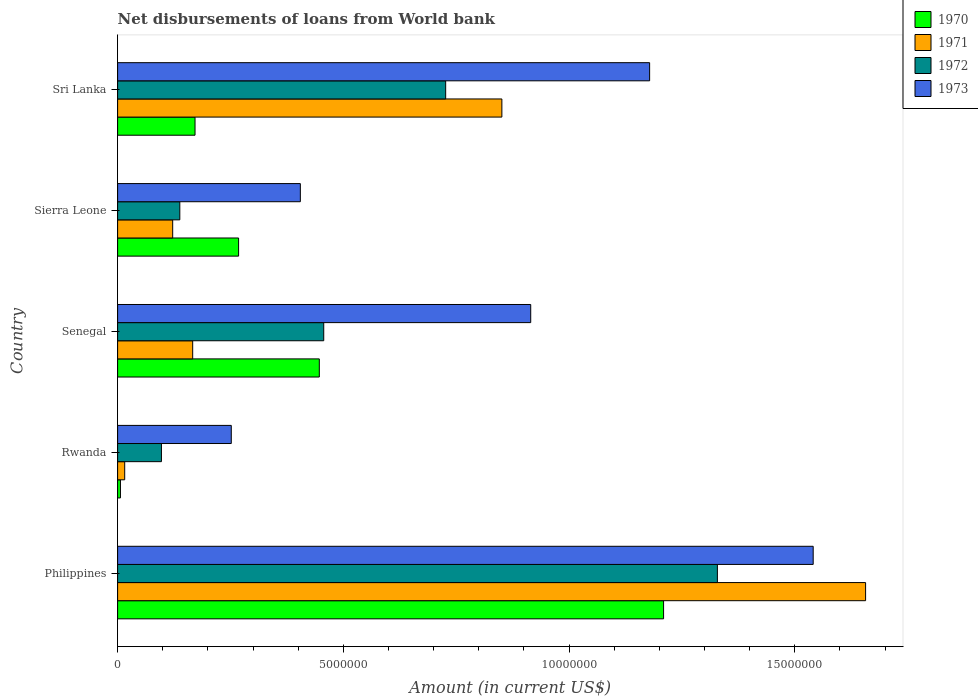Are the number of bars on each tick of the Y-axis equal?
Offer a terse response. Yes. How many bars are there on the 1st tick from the top?
Provide a short and direct response. 4. How many bars are there on the 1st tick from the bottom?
Give a very brief answer. 4. What is the label of the 1st group of bars from the top?
Your response must be concise. Sri Lanka. What is the amount of loan disbursed from World Bank in 1971 in Rwanda?
Your response must be concise. 1.57e+05. Across all countries, what is the maximum amount of loan disbursed from World Bank in 1970?
Provide a short and direct response. 1.21e+07. Across all countries, what is the minimum amount of loan disbursed from World Bank in 1970?
Give a very brief answer. 6.30e+04. In which country was the amount of loan disbursed from World Bank in 1973 maximum?
Your response must be concise. Philippines. In which country was the amount of loan disbursed from World Bank in 1973 minimum?
Ensure brevity in your answer.  Rwanda. What is the total amount of loan disbursed from World Bank in 1971 in the graph?
Provide a short and direct response. 2.81e+07. What is the difference between the amount of loan disbursed from World Bank in 1973 in Philippines and that in Sierra Leone?
Your response must be concise. 1.14e+07. What is the difference between the amount of loan disbursed from World Bank in 1971 in Rwanda and the amount of loan disbursed from World Bank in 1970 in Philippines?
Make the answer very short. -1.19e+07. What is the average amount of loan disbursed from World Bank in 1971 per country?
Make the answer very short. 5.62e+06. What is the difference between the amount of loan disbursed from World Bank in 1972 and amount of loan disbursed from World Bank in 1970 in Rwanda?
Provide a short and direct response. 9.08e+05. In how many countries, is the amount of loan disbursed from World Bank in 1970 greater than 1000000 US$?
Give a very brief answer. 4. What is the ratio of the amount of loan disbursed from World Bank in 1971 in Rwanda to that in Senegal?
Your response must be concise. 0.09. What is the difference between the highest and the second highest amount of loan disbursed from World Bank in 1973?
Give a very brief answer. 3.62e+06. What is the difference between the highest and the lowest amount of loan disbursed from World Bank in 1970?
Your response must be concise. 1.20e+07. In how many countries, is the amount of loan disbursed from World Bank in 1971 greater than the average amount of loan disbursed from World Bank in 1971 taken over all countries?
Offer a very short reply. 2. Is the sum of the amount of loan disbursed from World Bank in 1971 in Sierra Leone and Sri Lanka greater than the maximum amount of loan disbursed from World Bank in 1970 across all countries?
Give a very brief answer. No. What does the 3rd bar from the top in Senegal represents?
Make the answer very short. 1971. How many bars are there?
Offer a very short reply. 20. Are all the bars in the graph horizontal?
Offer a very short reply. Yes. What is the difference between two consecutive major ticks on the X-axis?
Provide a short and direct response. 5.00e+06. Does the graph contain any zero values?
Your response must be concise. No. Does the graph contain grids?
Make the answer very short. No. What is the title of the graph?
Your response must be concise. Net disbursements of loans from World bank. Does "2005" appear as one of the legend labels in the graph?
Offer a very short reply. No. What is the label or title of the X-axis?
Your answer should be very brief. Amount (in current US$). What is the Amount (in current US$) of 1970 in Philippines?
Your answer should be compact. 1.21e+07. What is the Amount (in current US$) of 1971 in Philippines?
Your answer should be compact. 1.66e+07. What is the Amount (in current US$) of 1972 in Philippines?
Ensure brevity in your answer.  1.33e+07. What is the Amount (in current US$) in 1973 in Philippines?
Provide a short and direct response. 1.54e+07. What is the Amount (in current US$) of 1970 in Rwanda?
Your answer should be compact. 6.30e+04. What is the Amount (in current US$) in 1971 in Rwanda?
Make the answer very short. 1.57e+05. What is the Amount (in current US$) of 1972 in Rwanda?
Your response must be concise. 9.71e+05. What is the Amount (in current US$) in 1973 in Rwanda?
Provide a succinct answer. 2.52e+06. What is the Amount (in current US$) in 1970 in Senegal?
Your answer should be very brief. 4.47e+06. What is the Amount (in current US$) in 1971 in Senegal?
Provide a succinct answer. 1.66e+06. What is the Amount (in current US$) of 1972 in Senegal?
Offer a very short reply. 4.57e+06. What is the Amount (in current US$) of 1973 in Senegal?
Keep it short and to the point. 9.15e+06. What is the Amount (in current US$) in 1970 in Sierra Leone?
Offer a very short reply. 2.68e+06. What is the Amount (in current US$) of 1971 in Sierra Leone?
Offer a terse response. 1.22e+06. What is the Amount (in current US$) of 1972 in Sierra Leone?
Keep it short and to the point. 1.38e+06. What is the Amount (in current US$) in 1973 in Sierra Leone?
Offer a very short reply. 4.05e+06. What is the Amount (in current US$) in 1970 in Sri Lanka?
Keep it short and to the point. 1.72e+06. What is the Amount (in current US$) of 1971 in Sri Lanka?
Your response must be concise. 8.51e+06. What is the Amount (in current US$) in 1972 in Sri Lanka?
Your response must be concise. 7.27e+06. What is the Amount (in current US$) in 1973 in Sri Lanka?
Provide a succinct answer. 1.18e+07. Across all countries, what is the maximum Amount (in current US$) of 1970?
Keep it short and to the point. 1.21e+07. Across all countries, what is the maximum Amount (in current US$) of 1971?
Keep it short and to the point. 1.66e+07. Across all countries, what is the maximum Amount (in current US$) of 1972?
Your answer should be compact. 1.33e+07. Across all countries, what is the maximum Amount (in current US$) of 1973?
Your answer should be very brief. 1.54e+07. Across all countries, what is the minimum Amount (in current US$) in 1970?
Provide a succinct answer. 6.30e+04. Across all countries, what is the minimum Amount (in current US$) in 1971?
Your answer should be compact. 1.57e+05. Across all countries, what is the minimum Amount (in current US$) of 1972?
Your response must be concise. 9.71e+05. Across all countries, what is the minimum Amount (in current US$) in 1973?
Provide a succinct answer. 2.52e+06. What is the total Amount (in current US$) in 1970 in the graph?
Your response must be concise. 2.10e+07. What is the total Amount (in current US$) of 1971 in the graph?
Your answer should be very brief. 2.81e+07. What is the total Amount (in current US$) in 1972 in the graph?
Make the answer very short. 2.75e+07. What is the total Amount (in current US$) of 1973 in the graph?
Keep it short and to the point. 4.29e+07. What is the difference between the Amount (in current US$) in 1970 in Philippines and that in Rwanda?
Ensure brevity in your answer.  1.20e+07. What is the difference between the Amount (in current US$) of 1971 in Philippines and that in Rwanda?
Give a very brief answer. 1.64e+07. What is the difference between the Amount (in current US$) in 1972 in Philippines and that in Rwanda?
Provide a short and direct response. 1.23e+07. What is the difference between the Amount (in current US$) in 1973 in Philippines and that in Rwanda?
Offer a terse response. 1.29e+07. What is the difference between the Amount (in current US$) in 1970 in Philippines and that in Senegal?
Your answer should be compact. 7.63e+06. What is the difference between the Amount (in current US$) in 1971 in Philippines and that in Senegal?
Your response must be concise. 1.49e+07. What is the difference between the Amount (in current US$) of 1972 in Philippines and that in Senegal?
Keep it short and to the point. 8.72e+06. What is the difference between the Amount (in current US$) of 1973 in Philippines and that in Senegal?
Give a very brief answer. 6.26e+06. What is the difference between the Amount (in current US$) in 1970 in Philippines and that in Sierra Leone?
Make the answer very short. 9.41e+06. What is the difference between the Amount (in current US$) of 1971 in Philippines and that in Sierra Leone?
Make the answer very short. 1.53e+07. What is the difference between the Amount (in current US$) in 1972 in Philippines and that in Sierra Leone?
Provide a short and direct response. 1.19e+07. What is the difference between the Amount (in current US$) of 1973 in Philippines and that in Sierra Leone?
Your answer should be compact. 1.14e+07. What is the difference between the Amount (in current US$) of 1970 in Philippines and that in Sri Lanka?
Offer a very short reply. 1.04e+07. What is the difference between the Amount (in current US$) in 1971 in Philippines and that in Sri Lanka?
Keep it short and to the point. 8.06e+06. What is the difference between the Amount (in current US$) of 1972 in Philippines and that in Sri Lanka?
Your answer should be compact. 6.02e+06. What is the difference between the Amount (in current US$) in 1973 in Philippines and that in Sri Lanka?
Give a very brief answer. 3.62e+06. What is the difference between the Amount (in current US$) of 1970 in Rwanda and that in Senegal?
Ensure brevity in your answer.  -4.40e+06. What is the difference between the Amount (in current US$) of 1971 in Rwanda and that in Senegal?
Provide a short and direct response. -1.51e+06. What is the difference between the Amount (in current US$) in 1972 in Rwanda and that in Senegal?
Ensure brevity in your answer.  -3.60e+06. What is the difference between the Amount (in current US$) of 1973 in Rwanda and that in Senegal?
Your answer should be very brief. -6.63e+06. What is the difference between the Amount (in current US$) of 1970 in Rwanda and that in Sierra Leone?
Your response must be concise. -2.62e+06. What is the difference between the Amount (in current US$) of 1971 in Rwanda and that in Sierra Leone?
Ensure brevity in your answer.  -1.06e+06. What is the difference between the Amount (in current US$) in 1972 in Rwanda and that in Sierra Leone?
Offer a terse response. -4.07e+05. What is the difference between the Amount (in current US$) of 1973 in Rwanda and that in Sierra Leone?
Your response must be concise. -1.53e+06. What is the difference between the Amount (in current US$) of 1970 in Rwanda and that in Sri Lanka?
Your response must be concise. -1.65e+06. What is the difference between the Amount (in current US$) in 1971 in Rwanda and that in Sri Lanka?
Offer a very short reply. -8.36e+06. What is the difference between the Amount (in current US$) in 1972 in Rwanda and that in Sri Lanka?
Your answer should be very brief. -6.30e+06. What is the difference between the Amount (in current US$) of 1973 in Rwanda and that in Sri Lanka?
Offer a very short reply. -9.27e+06. What is the difference between the Amount (in current US$) in 1970 in Senegal and that in Sierra Leone?
Your response must be concise. 1.79e+06. What is the difference between the Amount (in current US$) of 1971 in Senegal and that in Sierra Leone?
Keep it short and to the point. 4.43e+05. What is the difference between the Amount (in current US$) in 1972 in Senegal and that in Sierra Leone?
Provide a short and direct response. 3.19e+06. What is the difference between the Amount (in current US$) of 1973 in Senegal and that in Sierra Leone?
Offer a terse response. 5.10e+06. What is the difference between the Amount (in current US$) in 1970 in Senegal and that in Sri Lanka?
Ensure brevity in your answer.  2.75e+06. What is the difference between the Amount (in current US$) of 1971 in Senegal and that in Sri Lanka?
Your response must be concise. -6.85e+06. What is the difference between the Amount (in current US$) in 1972 in Senegal and that in Sri Lanka?
Keep it short and to the point. -2.70e+06. What is the difference between the Amount (in current US$) in 1973 in Senegal and that in Sri Lanka?
Your answer should be very brief. -2.63e+06. What is the difference between the Amount (in current US$) of 1970 in Sierra Leone and that in Sri Lanka?
Provide a succinct answer. 9.65e+05. What is the difference between the Amount (in current US$) of 1971 in Sierra Leone and that in Sri Lanka?
Keep it short and to the point. -7.29e+06. What is the difference between the Amount (in current US$) in 1972 in Sierra Leone and that in Sri Lanka?
Provide a succinct answer. -5.89e+06. What is the difference between the Amount (in current US$) of 1973 in Sierra Leone and that in Sri Lanka?
Provide a short and direct response. -7.74e+06. What is the difference between the Amount (in current US$) in 1970 in Philippines and the Amount (in current US$) in 1971 in Rwanda?
Offer a terse response. 1.19e+07. What is the difference between the Amount (in current US$) of 1970 in Philippines and the Amount (in current US$) of 1972 in Rwanda?
Your response must be concise. 1.11e+07. What is the difference between the Amount (in current US$) of 1970 in Philippines and the Amount (in current US$) of 1973 in Rwanda?
Offer a terse response. 9.58e+06. What is the difference between the Amount (in current US$) in 1971 in Philippines and the Amount (in current US$) in 1972 in Rwanda?
Ensure brevity in your answer.  1.56e+07. What is the difference between the Amount (in current US$) of 1971 in Philippines and the Amount (in current US$) of 1973 in Rwanda?
Keep it short and to the point. 1.41e+07. What is the difference between the Amount (in current US$) of 1972 in Philippines and the Amount (in current US$) of 1973 in Rwanda?
Your answer should be compact. 1.08e+07. What is the difference between the Amount (in current US$) of 1970 in Philippines and the Amount (in current US$) of 1971 in Senegal?
Provide a succinct answer. 1.04e+07. What is the difference between the Amount (in current US$) of 1970 in Philippines and the Amount (in current US$) of 1972 in Senegal?
Make the answer very short. 7.53e+06. What is the difference between the Amount (in current US$) in 1970 in Philippines and the Amount (in current US$) in 1973 in Senegal?
Ensure brevity in your answer.  2.94e+06. What is the difference between the Amount (in current US$) of 1971 in Philippines and the Amount (in current US$) of 1972 in Senegal?
Provide a short and direct response. 1.20e+07. What is the difference between the Amount (in current US$) in 1971 in Philippines and the Amount (in current US$) in 1973 in Senegal?
Provide a succinct answer. 7.42e+06. What is the difference between the Amount (in current US$) in 1972 in Philippines and the Amount (in current US$) in 1973 in Senegal?
Make the answer very short. 4.14e+06. What is the difference between the Amount (in current US$) in 1970 in Philippines and the Amount (in current US$) in 1971 in Sierra Leone?
Make the answer very short. 1.09e+07. What is the difference between the Amount (in current US$) in 1970 in Philippines and the Amount (in current US$) in 1972 in Sierra Leone?
Make the answer very short. 1.07e+07. What is the difference between the Amount (in current US$) of 1970 in Philippines and the Amount (in current US$) of 1973 in Sierra Leone?
Offer a very short reply. 8.05e+06. What is the difference between the Amount (in current US$) of 1971 in Philippines and the Amount (in current US$) of 1972 in Sierra Leone?
Your response must be concise. 1.52e+07. What is the difference between the Amount (in current US$) of 1971 in Philippines and the Amount (in current US$) of 1973 in Sierra Leone?
Ensure brevity in your answer.  1.25e+07. What is the difference between the Amount (in current US$) in 1972 in Philippines and the Amount (in current US$) in 1973 in Sierra Leone?
Your answer should be compact. 9.24e+06. What is the difference between the Amount (in current US$) in 1970 in Philippines and the Amount (in current US$) in 1971 in Sri Lanka?
Keep it short and to the point. 3.58e+06. What is the difference between the Amount (in current US$) in 1970 in Philippines and the Amount (in current US$) in 1972 in Sri Lanka?
Provide a short and direct response. 4.83e+06. What is the difference between the Amount (in current US$) of 1970 in Philippines and the Amount (in current US$) of 1973 in Sri Lanka?
Offer a terse response. 3.09e+05. What is the difference between the Amount (in current US$) of 1971 in Philippines and the Amount (in current US$) of 1972 in Sri Lanka?
Your answer should be very brief. 9.30e+06. What is the difference between the Amount (in current US$) of 1971 in Philippines and the Amount (in current US$) of 1973 in Sri Lanka?
Keep it short and to the point. 4.78e+06. What is the difference between the Amount (in current US$) of 1972 in Philippines and the Amount (in current US$) of 1973 in Sri Lanka?
Provide a short and direct response. 1.50e+06. What is the difference between the Amount (in current US$) of 1970 in Rwanda and the Amount (in current US$) of 1971 in Senegal?
Your answer should be very brief. -1.60e+06. What is the difference between the Amount (in current US$) of 1970 in Rwanda and the Amount (in current US$) of 1972 in Senegal?
Offer a very short reply. -4.50e+06. What is the difference between the Amount (in current US$) of 1970 in Rwanda and the Amount (in current US$) of 1973 in Senegal?
Ensure brevity in your answer.  -9.09e+06. What is the difference between the Amount (in current US$) in 1971 in Rwanda and the Amount (in current US$) in 1972 in Senegal?
Give a very brief answer. -4.41e+06. What is the difference between the Amount (in current US$) of 1971 in Rwanda and the Amount (in current US$) of 1973 in Senegal?
Offer a terse response. -8.99e+06. What is the difference between the Amount (in current US$) in 1972 in Rwanda and the Amount (in current US$) in 1973 in Senegal?
Provide a succinct answer. -8.18e+06. What is the difference between the Amount (in current US$) of 1970 in Rwanda and the Amount (in current US$) of 1971 in Sierra Leone?
Ensure brevity in your answer.  -1.16e+06. What is the difference between the Amount (in current US$) in 1970 in Rwanda and the Amount (in current US$) in 1972 in Sierra Leone?
Your answer should be compact. -1.32e+06. What is the difference between the Amount (in current US$) in 1970 in Rwanda and the Amount (in current US$) in 1973 in Sierra Leone?
Your answer should be very brief. -3.98e+06. What is the difference between the Amount (in current US$) of 1971 in Rwanda and the Amount (in current US$) of 1972 in Sierra Leone?
Offer a very short reply. -1.22e+06. What is the difference between the Amount (in current US$) in 1971 in Rwanda and the Amount (in current US$) in 1973 in Sierra Leone?
Make the answer very short. -3.89e+06. What is the difference between the Amount (in current US$) in 1972 in Rwanda and the Amount (in current US$) in 1973 in Sierra Leone?
Provide a short and direct response. -3.08e+06. What is the difference between the Amount (in current US$) in 1970 in Rwanda and the Amount (in current US$) in 1971 in Sri Lanka?
Keep it short and to the point. -8.45e+06. What is the difference between the Amount (in current US$) in 1970 in Rwanda and the Amount (in current US$) in 1972 in Sri Lanka?
Your answer should be very brief. -7.20e+06. What is the difference between the Amount (in current US$) of 1970 in Rwanda and the Amount (in current US$) of 1973 in Sri Lanka?
Your answer should be compact. -1.17e+07. What is the difference between the Amount (in current US$) in 1971 in Rwanda and the Amount (in current US$) in 1972 in Sri Lanka?
Offer a terse response. -7.11e+06. What is the difference between the Amount (in current US$) in 1971 in Rwanda and the Amount (in current US$) in 1973 in Sri Lanka?
Keep it short and to the point. -1.16e+07. What is the difference between the Amount (in current US$) of 1972 in Rwanda and the Amount (in current US$) of 1973 in Sri Lanka?
Your response must be concise. -1.08e+07. What is the difference between the Amount (in current US$) in 1970 in Senegal and the Amount (in current US$) in 1971 in Sierra Leone?
Your answer should be very brief. 3.25e+06. What is the difference between the Amount (in current US$) in 1970 in Senegal and the Amount (in current US$) in 1972 in Sierra Leone?
Keep it short and to the point. 3.09e+06. What is the difference between the Amount (in current US$) in 1970 in Senegal and the Amount (in current US$) in 1973 in Sierra Leone?
Keep it short and to the point. 4.20e+05. What is the difference between the Amount (in current US$) of 1971 in Senegal and the Amount (in current US$) of 1972 in Sierra Leone?
Provide a succinct answer. 2.85e+05. What is the difference between the Amount (in current US$) of 1971 in Senegal and the Amount (in current US$) of 1973 in Sierra Leone?
Your response must be concise. -2.38e+06. What is the difference between the Amount (in current US$) in 1972 in Senegal and the Amount (in current US$) in 1973 in Sierra Leone?
Your response must be concise. 5.18e+05. What is the difference between the Amount (in current US$) of 1970 in Senegal and the Amount (in current US$) of 1971 in Sri Lanka?
Keep it short and to the point. -4.04e+06. What is the difference between the Amount (in current US$) of 1970 in Senegal and the Amount (in current US$) of 1972 in Sri Lanka?
Provide a short and direct response. -2.80e+06. What is the difference between the Amount (in current US$) of 1970 in Senegal and the Amount (in current US$) of 1973 in Sri Lanka?
Offer a very short reply. -7.32e+06. What is the difference between the Amount (in current US$) in 1971 in Senegal and the Amount (in current US$) in 1972 in Sri Lanka?
Your response must be concise. -5.60e+06. What is the difference between the Amount (in current US$) in 1971 in Senegal and the Amount (in current US$) in 1973 in Sri Lanka?
Make the answer very short. -1.01e+07. What is the difference between the Amount (in current US$) in 1972 in Senegal and the Amount (in current US$) in 1973 in Sri Lanka?
Keep it short and to the point. -7.22e+06. What is the difference between the Amount (in current US$) in 1970 in Sierra Leone and the Amount (in current US$) in 1971 in Sri Lanka?
Give a very brief answer. -5.83e+06. What is the difference between the Amount (in current US$) of 1970 in Sierra Leone and the Amount (in current US$) of 1972 in Sri Lanka?
Your response must be concise. -4.59e+06. What is the difference between the Amount (in current US$) of 1970 in Sierra Leone and the Amount (in current US$) of 1973 in Sri Lanka?
Keep it short and to the point. -9.10e+06. What is the difference between the Amount (in current US$) in 1971 in Sierra Leone and the Amount (in current US$) in 1972 in Sri Lanka?
Ensure brevity in your answer.  -6.05e+06. What is the difference between the Amount (in current US$) in 1971 in Sierra Leone and the Amount (in current US$) in 1973 in Sri Lanka?
Keep it short and to the point. -1.06e+07. What is the difference between the Amount (in current US$) of 1972 in Sierra Leone and the Amount (in current US$) of 1973 in Sri Lanka?
Your response must be concise. -1.04e+07. What is the average Amount (in current US$) of 1970 per country?
Your answer should be compact. 4.20e+06. What is the average Amount (in current US$) of 1971 per country?
Make the answer very short. 5.62e+06. What is the average Amount (in current US$) of 1972 per country?
Provide a succinct answer. 5.49e+06. What is the average Amount (in current US$) in 1973 per country?
Provide a succinct answer. 8.58e+06. What is the difference between the Amount (in current US$) of 1970 and Amount (in current US$) of 1971 in Philippines?
Offer a terse response. -4.48e+06. What is the difference between the Amount (in current US$) in 1970 and Amount (in current US$) in 1972 in Philippines?
Your answer should be very brief. -1.19e+06. What is the difference between the Amount (in current US$) in 1970 and Amount (in current US$) in 1973 in Philippines?
Keep it short and to the point. -3.31e+06. What is the difference between the Amount (in current US$) in 1971 and Amount (in current US$) in 1972 in Philippines?
Offer a terse response. 3.28e+06. What is the difference between the Amount (in current US$) of 1971 and Amount (in current US$) of 1973 in Philippines?
Offer a terse response. 1.16e+06. What is the difference between the Amount (in current US$) in 1972 and Amount (in current US$) in 1973 in Philippines?
Offer a very short reply. -2.12e+06. What is the difference between the Amount (in current US$) in 1970 and Amount (in current US$) in 1971 in Rwanda?
Offer a terse response. -9.40e+04. What is the difference between the Amount (in current US$) in 1970 and Amount (in current US$) in 1972 in Rwanda?
Offer a very short reply. -9.08e+05. What is the difference between the Amount (in current US$) of 1970 and Amount (in current US$) of 1973 in Rwanda?
Give a very brief answer. -2.46e+06. What is the difference between the Amount (in current US$) of 1971 and Amount (in current US$) of 1972 in Rwanda?
Your answer should be very brief. -8.14e+05. What is the difference between the Amount (in current US$) in 1971 and Amount (in current US$) in 1973 in Rwanda?
Your response must be concise. -2.36e+06. What is the difference between the Amount (in current US$) in 1972 and Amount (in current US$) in 1973 in Rwanda?
Your answer should be compact. -1.55e+06. What is the difference between the Amount (in current US$) of 1970 and Amount (in current US$) of 1971 in Senegal?
Offer a very short reply. 2.80e+06. What is the difference between the Amount (in current US$) of 1970 and Amount (in current US$) of 1972 in Senegal?
Your answer should be very brief. -9.80e+04. What is the difference between the Amount (in current US$) in 1970 and Amount (in current US$) in 1973 in Senegal?
Your response must be concise. -4.68e+06. What is the difference between the Amount (in current US$) in 1971 and Amount (in current US$) in 1972 in Senegal?
Offer a very short reply. -2.90e+06. What is the difference between the Amount (in current US$) of 1971 and Amount (in current US$) of 1973 in Senegal?
Provide a short and direct response. -7.49e+06. What is the difference between the Amount (in current US$) of 1972 and Amount (in current US$) of 1973 in Senegal?
Provide a succinct answer. -4.58e+06. What is the difference between the Amount (in current US$) in 1970 and Amount (in current US$) in 1971 in Sierra Leone?
Provide a short and direct response. 1.46e+06. What is the difference between the Amount (in current US$) of 1970 and Amount (in current US$) of 1972 in Sierra Leone?
Ensure brevity in your answer.  1.30e+06. What is the difference between the Amount (in current US$) in 1970 and Amount (in current US$) in 1973 in Sierra Leone?
Provide a short and direct response. -1.37e+06. What is the difference between the Amount (in current US$) of 1971 and Amount (in current US$) of 1972 in Sierra Leone?
Your response must be concise. -1.58e+05. What is the difference between the Amount (in current US$) of 1971 and Amount (in current US$) of 1973 in Sierra Leone?
Provide a short and direct response. -2.83e+06. What is the difference between the Amount (in current US$) in 1972 and Amount (in current US$) in 1973 in Sierra Leone?
Your answer should be compact. -2.67e+06. What is the difference between the Amount (in current US$) in 1970 and Amount (in current US$) in 1971 in Sri Lanka?
Ensure brevity in your answer.  -6.80e+06. What is the difference between the Amount (in current US$) in 1970 and Amount (in current US$) in 1972 in Sri Lanka?
Keep it short and to the point. -5.55e+06. What is the difference between the Amount (in current US$) of 1970 and Amount (in current US$) of 1973 in Sri Lanka?
Your answer should be very brief. -1.01e+07. What is the difference between the Amount (in current US$) in 1971 and Amount (in current US$) in 1972 in Sri Lanka?
Make the answer very short. 1.24e+06. What is the difference between the Amount (in current US$) of 1971 and Amount (in current US$) of 1973 in Sri Lanka?
Offer a very short reply. -3.27e+06. What is the difference between the Amount (in current US$) of 1972 and Amount (in current US$) of 1973 in Sri Lanka?
Your response must be concise. -4.52e+06. What is the ratio of the Amount (in current US$) in 1970 in Philippines to that in Rwanda?
Your answer should be very brief. 191.97. What is the ratio of the Amount (in current US$) of 1971 in Philippines to that in Rwanda?
Provide a succinct answer. 105.53. What is the ratio of the Amount (in current US$) of 1972 in Philippines to that in Rwanda?
Offer a very short reply. 13.68. What is the ratio of the Amount (in current US$) of 1973 in Philippines to that in Rwanda?
Ensure brevity in your answer.  6.12. What is the ratio of the Amount (in current US$) in 1970 in Philippines to that in Senegal?
Provide a succinct answer. 2.71. What is the ratio of the Amount (in current US$) in 1971 in Philippines to that in Senegal?
Your answer should be very brief. 9.96. What is the ratio of the Amount (in current US$) in 1972 in Philippines to that in Senegal?
Make the answer very short. 2.91. What is the ratio of the Amount (in current US$) in 1973 in Philippines to that in Senegal?
Ensure brevity in your answer.  1.68. What is the ratio of the Amount (in current US$) in 1970 in Philippines to that in Sierra Leone?
Provide a short and direct response. 4.51. What is the ratio of the Amount (in current US$) in 1971 in Philippines to that in Sierra Leone?
Keep it short and to the point. 13.58. What is the ratio of the Amount (in current US$) in 1972 in Philippines to that in Sierra Leone?
Give a very brief answer. 9.64. What is the ratio of the Amount (in current US$) of 1973 in Philippines to that in Sierra Leone?
Your response must be concise. 3.81. What is the ratio of the Amount (in current US$) of 1970 in Philippines to that in Sri Lanka?
Ensure brevity in your answer.  7.05. What is the ratio of the Amount (in current US$) in 1971 in Philippines to that in Sri Lanka?
Keep it short and to the point. 1.95. What is the ratio of the Amount (in current US$) in 1972 in Philippines to that in Sri Lanka?
Your answer should be compact. 1.83. What is the ratio of the Amount (in current US$) of 1973 in Philippines to that in Sri Lanka?
Make the answer very short. 1.31. What is the ratio of the Amount (in current US$) of 1970 in Rwanda to that in Senegal?
Ensure brevity in your answer.  0.01. What is the ratio of the Amount (in current US$) in 1971 in Rwanda to that in Senegal?
Offer a terse response. 0.09. What is the ratio of the Amount (in current US$) in 1972 in Rwanda to that in Senegal?
Provide a succinct answer. 0.21. What is the ratio of the Amount (in current US$) in 1973 in Rwanda to that in Senegal?
Provide a succinct answer. 0.28. What is the ratio of the Amount (in current US$) of 1970 in Rwanda to that in Sierra Leone?
Your response must be concise. 0.02. What is the ratio of the Amount (in current US$) in 1971 in Rwanda to that in Sierra Leone?
Offer a terse response. 0.13. What is the ratio of the Amount (in current US$) of 1972 in Rwanda to that in Sierra Leone?
Ensure brevity in your answer.  0.7. What is the ratio of the Amount (in current US$) of 1973 in Rwanda to that in Sierra Leone?
Offer a very short reply. 0.62. What is the ratio of the Amount (in current US$) in 1970 in Rwanda to that in Sri Lanka?
Provide a succinct answer. 0.04. What is the ratio of the Amount (in current US$) of 1971 in Rwanda to that in Sri Lanka?
Your response must be concise. 0.02. What is the ratio of the Amount (in current US$) of 1972 in Rwanda to that in Sri Lanka?
Make the answer very short. 0.13. What is the ratio of the Amount (in current US$) in 1973 in Rwanda to that in Sri Lanka?
Offer a very short reply. 0.21. What is the ratio of the Amount (in current US$) of 1970 in Senegal to that in Sierra Leone?
Offer a very short reply. 1.67. What is the ratio of the Amount (in current US$) in 1971 in Senegal to that in Sierra Leone?
Provide a short and direct response. 1.36. What is the ratio of the Amount (in current US$) in 1972 in Senegal to that in Sierra Leone?
Your response must be concise. 3.31. What is the ratio of the Amount (in current US$) in 1973 in Senegal to that in Sierra Leone?
Keep it short and to the point. 2.26. What is the ratio of the Amount (in current US$) of 1970 in Senegal to that in Sri Lanka?
Your response must be concise. 2.61. What is the ratio of the Amount (in current US$) of 1971 in Senegal to that in Sri Lanka?
Offer a terse response. 0.2. What is the ratio of the Amount (in current US$) of 1972 in Senegal to that in Sri Lanka?
Your answer should be very brief. 0.63. What is the ratio of the Amount (in current US$) of 1973 in Senegal to that in Sri Lanka?
Offer a very short reply. 0.78. What is the ratio of the Amount (in current US$) of 1970 in Sierra Leone to that in Sri Lanka?
Offer a very short reply. 1.56. What is the ratio of the Amount (in current US$) of 1971 in Sierra Leone to that in Sri Lanka?
Give a very brief answer. 0.14. What is the ratio of the Amount (in current US$) in 1972 in Sierra Leone to that in Sri Lanka?
Your answer should be very brief. 0.19. What is the ratio of the Amount (in current US$) of 1973 in Sierra Leone to that in Sri Lanka?
Provide a short and direct response. 0.34. What is the difference between the highest and the second highest Amount (in current US$) in 1970?
Your answer should be very brief. 7.63e+06. What is the difference between the highest and the second highest Amount (in current US$) in 1971?
Offer a very short reply. 8.06e+06. What is the difference between the highest and the second highest Amount (in current US$) in 1972?
Your answer should be compact. 6.02e+06. What is the difference between the highest and the second highest Amount (in current US$) of 1973?
Make the answer very short. 3.62e+06. What is the difference between the highest and the lowest Amount (in current US$) in 1970?
Your answer should be compact. 1.20e+07. What is the difference between the highest and the lowest Amount (in current US$) in 1971?
Provide a succinct answer. 1.64e+07. What is the difference between the highest and the lowest Amount (in current US$) in 1972?
Your answer should be compact. 1.23e+07. What is the difference between the highest and the lowest Amount (in current US$) in 1973?
Your response must be concise. 1.29e+07. 